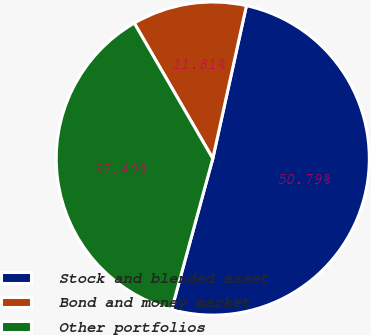<chart> <loc_0><loc_0><loc_500><loc_500><pie_chart><fcel>Stock and blended asset<fcel>Bond and money market<fcel>Other portfolios<nl><fcel>50.78%<fcel>11.81%<fcel>37.4%<nl></chart> 